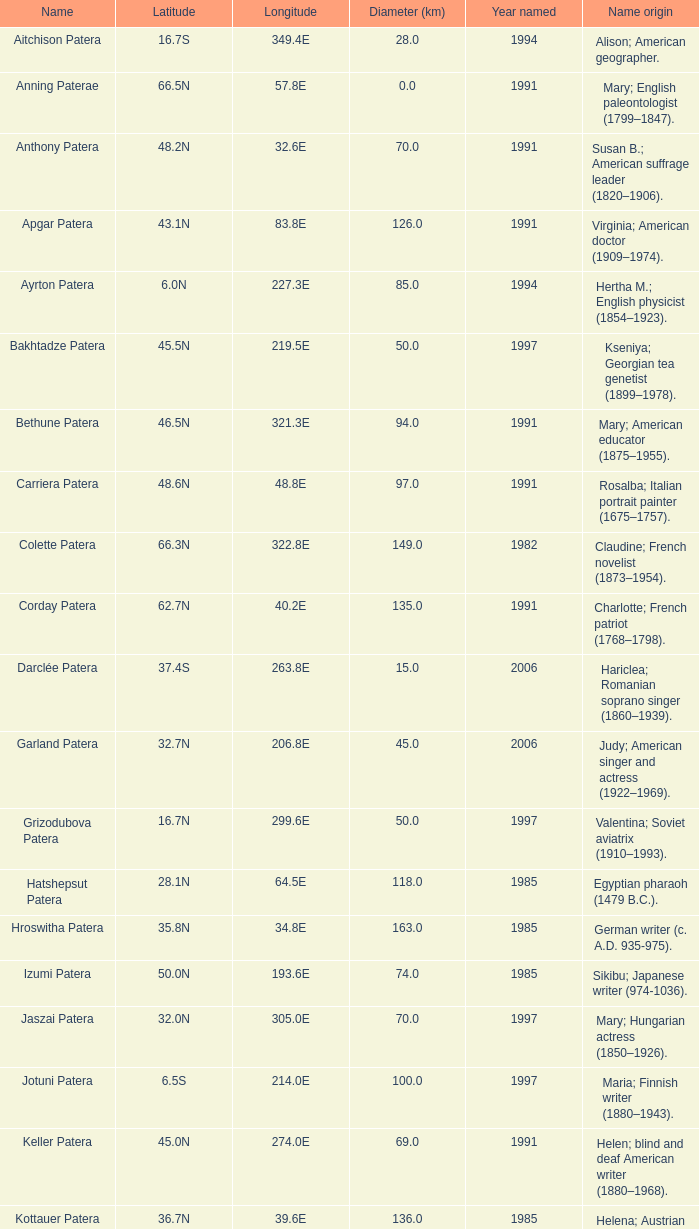Write the full table. {'header': ['Name', 'Latitude', 'Longitude', 'Diameter (km)', 'Year named', 'Name origin'], 'rows': [['Aitchison Patera', '16.7S', '349.4E', '28.0', '1994', 'Alison; American geographer.'], ['Anning Paterae', '66.5N', '57.8E', '0.0', '1991', 'Mary; English paleontologist (1799–1847).'], ['Anthony Patera', '48.2N', '32.6E', '70.0', '1991', 'Susan B.; American suffrage leader (1820–1906).'], ['Apgar Patera', '43.1N', '83.8E', '126.0', '1991', 'Virginia; American doctor (1909–1974).'], ['Ayrton Patera', '6.0N', '227.3E', '85.0', '1994', 'Hertha M.; English physicist (1854–1923).'], ['Bakhtadze Patera', '45.5N', '219.5E', '50.0', '1997', 'Kseniya; Georgian tea genetist (1899–1978).'], ['Bethune Patera', '46.5N', '321.3E', '94.0', '1991', 'Mary; American educator (1875–1955).'], ['Carriera Patera', '48.6N', '48.8E', '97.0', '1991', 'Rosalba; Italian portrait painter (1675–1757).'], ['Colette Patera', '66.3N', '322.8E', '149.0', '1982', 'Claudine; French novelist (1873–1954).'], ['Corday Patera', '62.7N', '40.2E', '135.0', '1991', 'Charlotte; French patriot (1768–1798).'], ['Darclée Patera', '37.4S', '263.8E', '15.0', '2006', 'Hariclea; Romanian soprano singer (1860–1939).'], ['Garland Patera', '32.7N', '206.8E', '45.0', '2006', 'Judy; American singer and actress (1922–1969).'], ['Grizodubova Patera', '16.7N', '299.6E', '50.0', '1997', 'Valentina; Soviet aviatrix (1910–1993).'], ['Hatshepsut Patera', '28.1N', '64.5E', '118.0', '1985', 'Egyptian pharaoh (1479 B.C.).'], ['Hroswitha Patera', '35.8N', '34.8E', '163.0', '1985', 'German writer (c. A.D. 935-975).'], ['Izumi Patera', '50.0N', '193.6E', '74.0', '1985', 'Sikibu; Japanese writer (974-1036).'], ['Jaszai Patera', '32.0N', '305.0E', '70.0', '1997', 'Mary; Hungarian actress (1850–1926).'], ['Jotuni Patera', '6.5S', '214.0E', '100.0', '1997', 'Maria; Finnish writer (1880–1943).'], ['Keller Patera', '45.0N', '274.0E', '69.0', '1991', 'Helen; blind and deaf American writer (1880–1968).'], ['Kottauer Patera', '36.7N', '39.6E', '136.0', '1985', 'Helena; Austrian historical writer (1410–1471).'], ['Kupo Patera', '41.9S', '195.5E', '100.0', '1997', 'Irena; Israelite astronomer (1929–1978).'], ['Ledoux Patera', '9.2S', '224.8E', '75.0', '1994', 'Jeanne; French artist (1767–1840).'], ['Lindgren Patera', '28.1N', '241.4E', '110.0', '2006', 'Astrid; Swedish author (1907–2002).'], ['Mehseti Patera', '16.0N', '311.0E', '60.0', '1997', 'Ganjevi; Azeri/Persian poet (c. 1050-c. 1100).'], ['Mezrina Patera', '33.3S', '68.8E', '60.0', '2000', 'Anna; Russian clay toy sculptor (1853–1938).'], ['Nordenflycht Patera', '35.0S', '266.0E', '140.0', '1997', 'Hedwig; Swedish poet (1718–1763).'], ['Panina Patera', '13.0S', '309.8E', '50.0', '1997', 'Varya; Gypsy/Russian singer (1872–1911).'], ['Payne-Gaposchkin Patera', '25.5S', '196.0E', '100.0', '1997', 'Cecilia Helena; American astronomer (1900–1979).'], ['Pocahontas Patera', '64.9N', '49.4E', '78.0', '1991', 'Powhatan Indian peacemaker (1595–1617).'], ['Raskova Paterae', '51.0S', '222.8E', '80.0', '1994', 'Marina M.; Russian aviator (1912–1943).'], ['Razia Patera', '46.2N', '197.8E', '157.0', '1985', 'Queen of Delhi Sultanate (India) (1236–1240).'], ['Shulzhenko Patera', '6.5N', '264.5E', '60.0', '1997', 'Klavdiya; Soviet singer (1906–1984).'], ['Siddons Patera', '61.6N', '340.6E', '47.0', '1997', 'Sarah; English actress (1755–1831).'], ['Stopes Patera', '42.6N', '46.5E', '169.0', '1991', 'Marie; English paleontologist (1880–1959).'], ['Tarbell Patera', '58.2S', '351.5E', '80.0', '1994', 'Ida; American author, editor (1857–1944).'], ['Teasdale Patera', '67.6S', '189.1E', '75.0', '1994', 'Sara; American poet (1884–1933).'], ['Tey Patera', '17.8S', '349.1E', '20.0', '1994', 'Josephine; Scottish author (1897–1952).'], ['Tipporah Patera', '38.9N', '43.0E', '99.0', '1985', 'Hebrew medical scholar (1500 B.C.).'], ['Vibert-Douglas Patera', '11.6S', '194.3E', '45.0', '2003', 'Allie; Canadian astronomer (1894–1988).'], ['Villepreux-Power Patera', '22.0S', '210.0E', '100.0', '1997', 'Jeannette; French marine biologist (1794–1871).'], ['Wilde Patera', '21.3S', '266.3E', '75.0', '2000', 'Lady Jane Francesca; Irish poet (1821–1891).'], ['Witte Patera', '25.8S', '247.65E', '35.0', '2006', 'Wilhelmine; German astronomer (1777–1854).'], ['Woodhull Patera', '37.4N', '305.4E', '83.0', '1991', 'Victoria; American-English lecturer (1838–1927).']]} What is the origin of the name of Keller Patera?  Helen; blind and deaf American writer (1880–1968). 